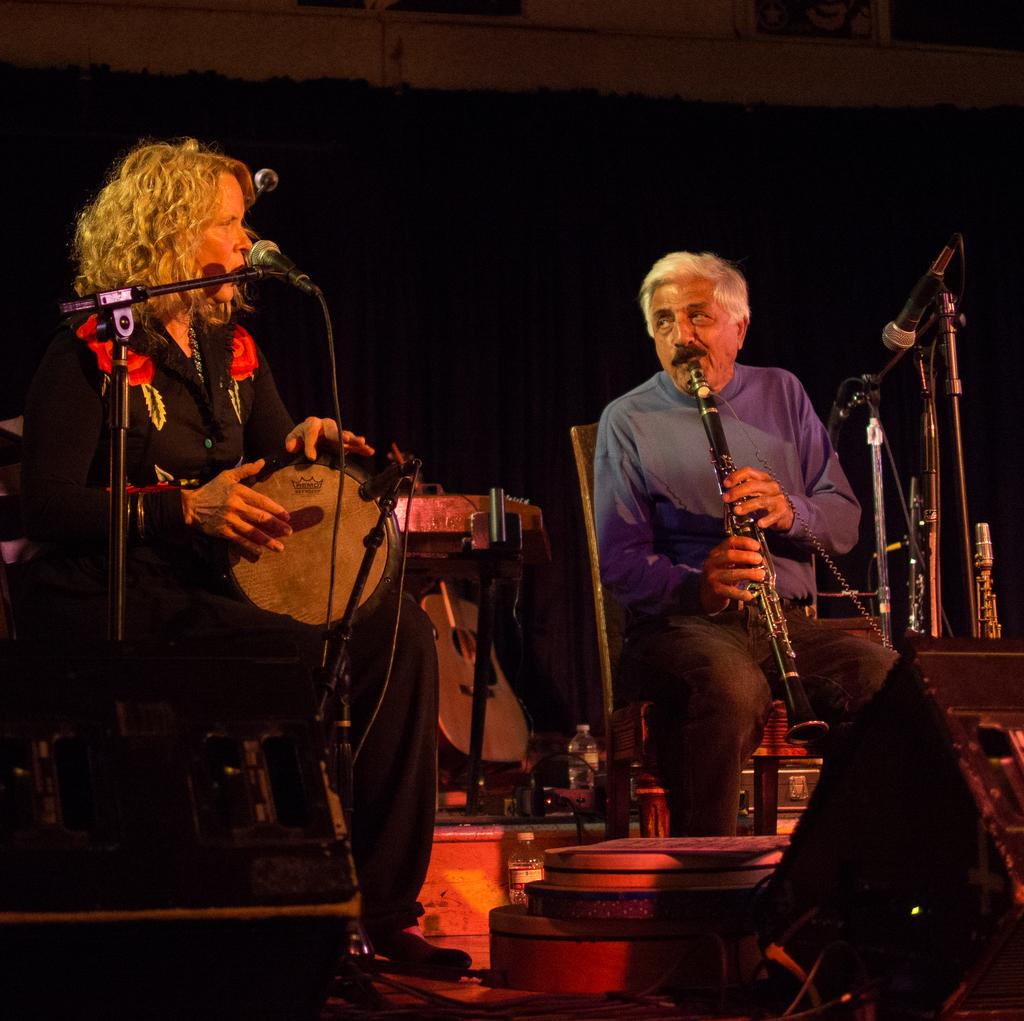How many people are in the image? There are two people in the image. What are the people doing in the image? The people are sitting on chairs and playing musical instruments. What is in front of the people? There is a microphone in front of the people. What else can be seen in the image related to music? There are speakers and other musical instruments visible in the image. What type of pen is being used by the people to write music in the image? There is no pen visible in the image, and the people are playing musical instruments, not writing music. 